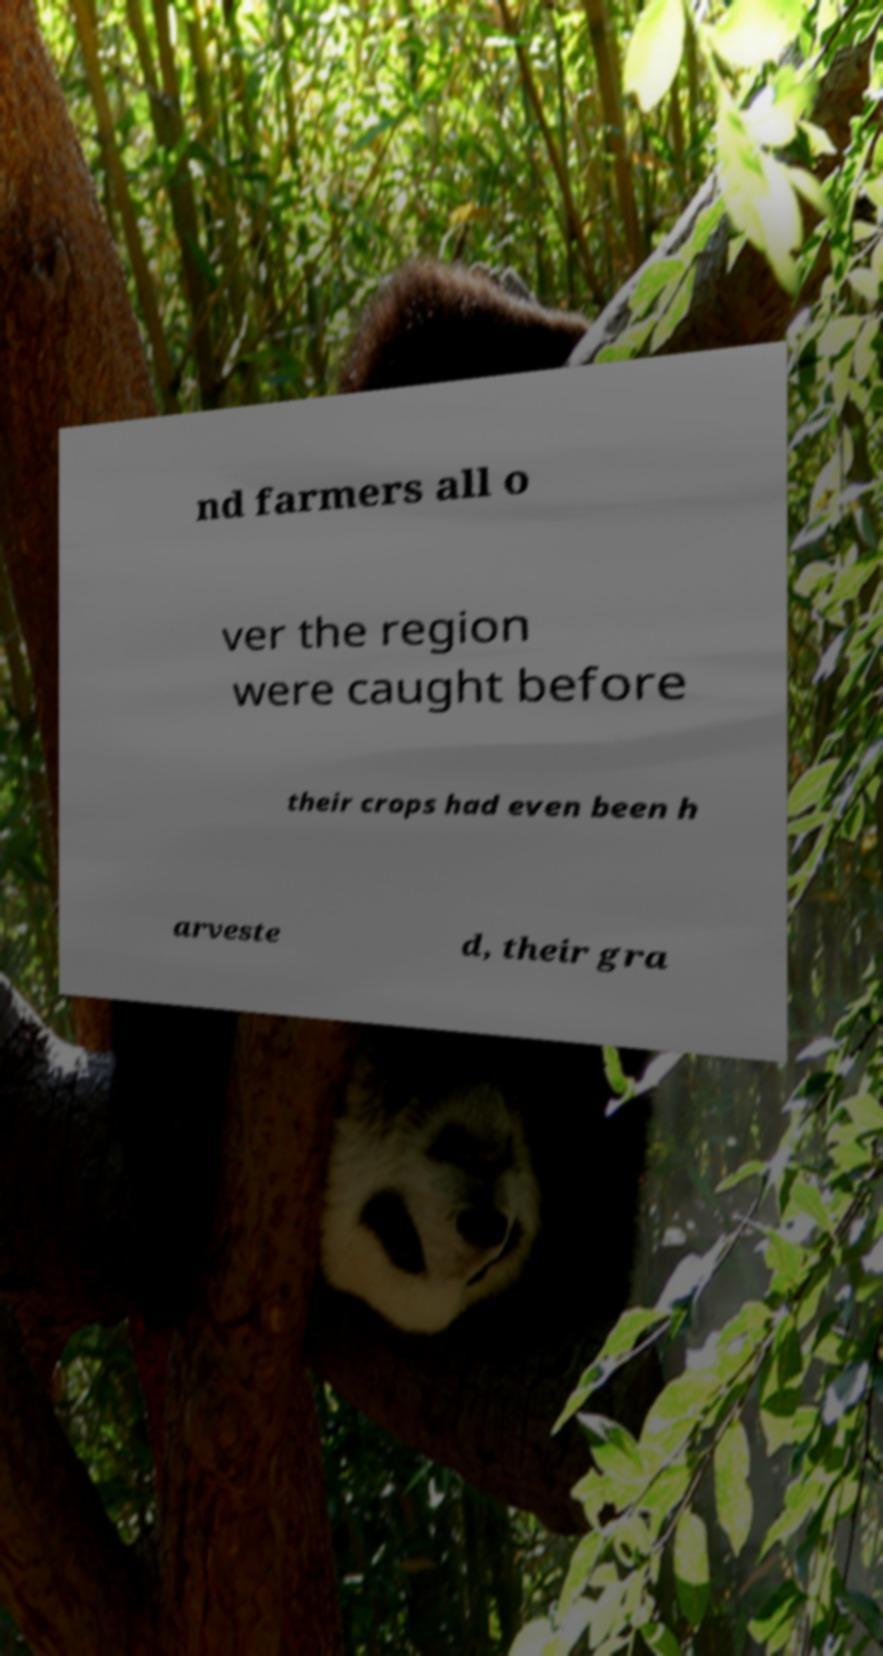There's text embedded in this image that I need extracted. Can you transcribe it verbatim? nd farmers all o ver the region were caught before their crops had even been h arveste d, their gra 